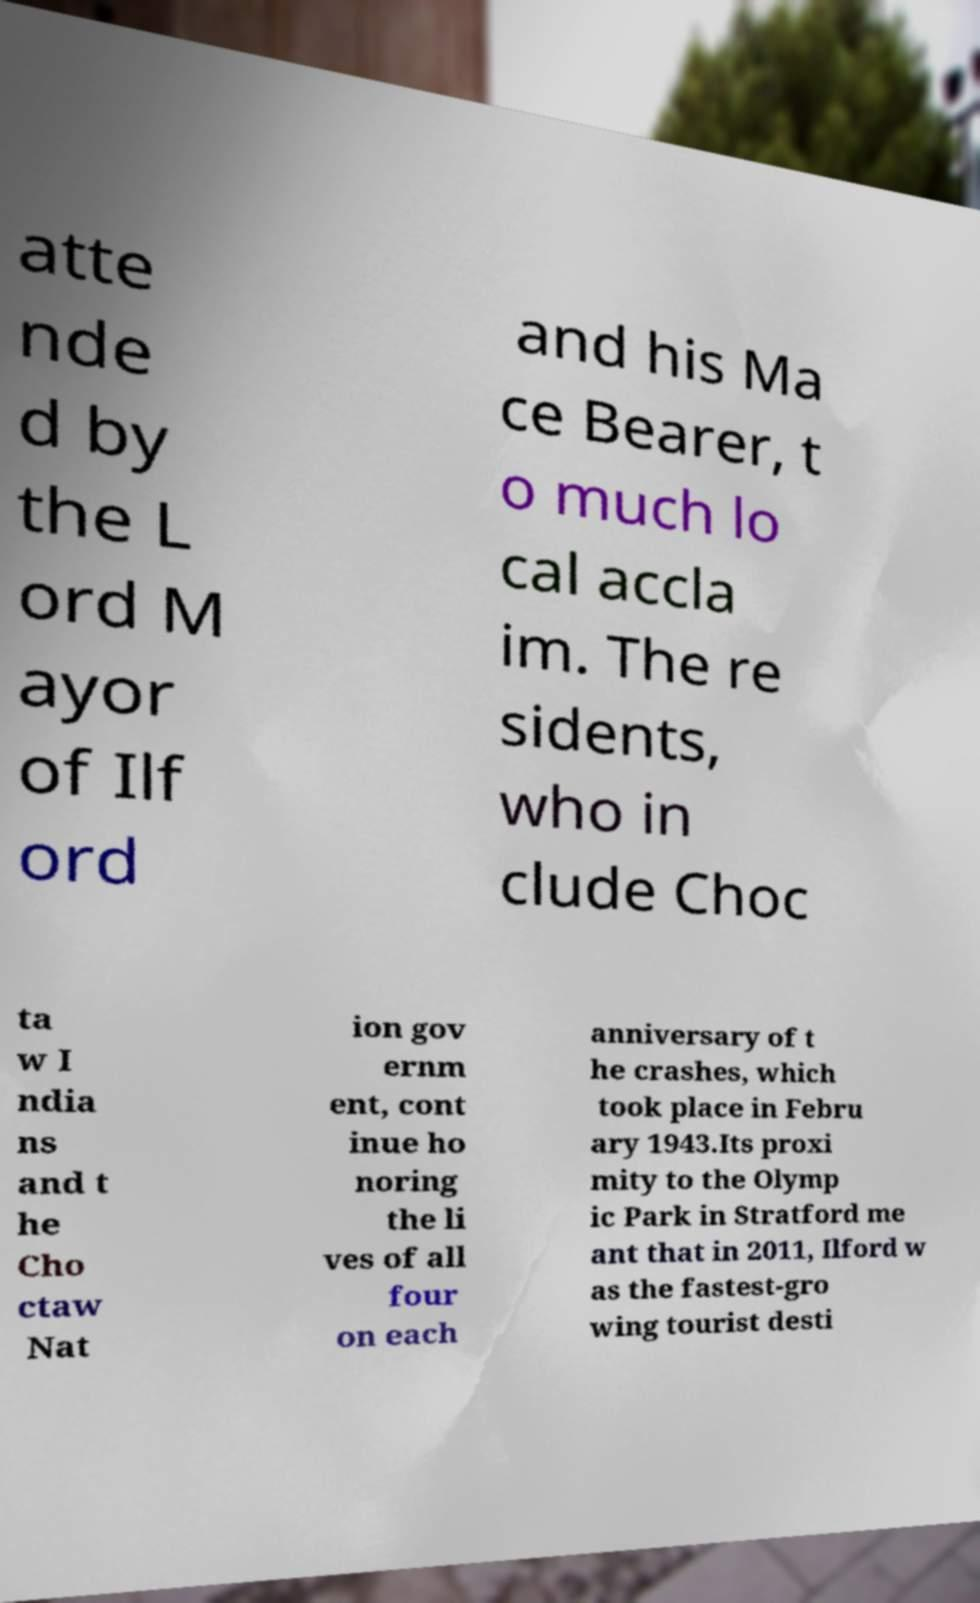Please read and relay the text visible in this image. What does it say? atte nde d by the L ord M ayor of Ilf ord and his Ma ce Bearer, t o much lo cal accla im. The re sidents, who in clude Choc ta w I ndia ns and t he Cho ctaw Nat ion gov ernm ent, cont inue ho noring the li ves of all four on each anniversary of t he crashes, which took place in Febru ary 1943.Its proxi mity to the Olymp ic Park in Stratford me ant that in 2011, Ilford w as the fastest-gro wing tourist desti 